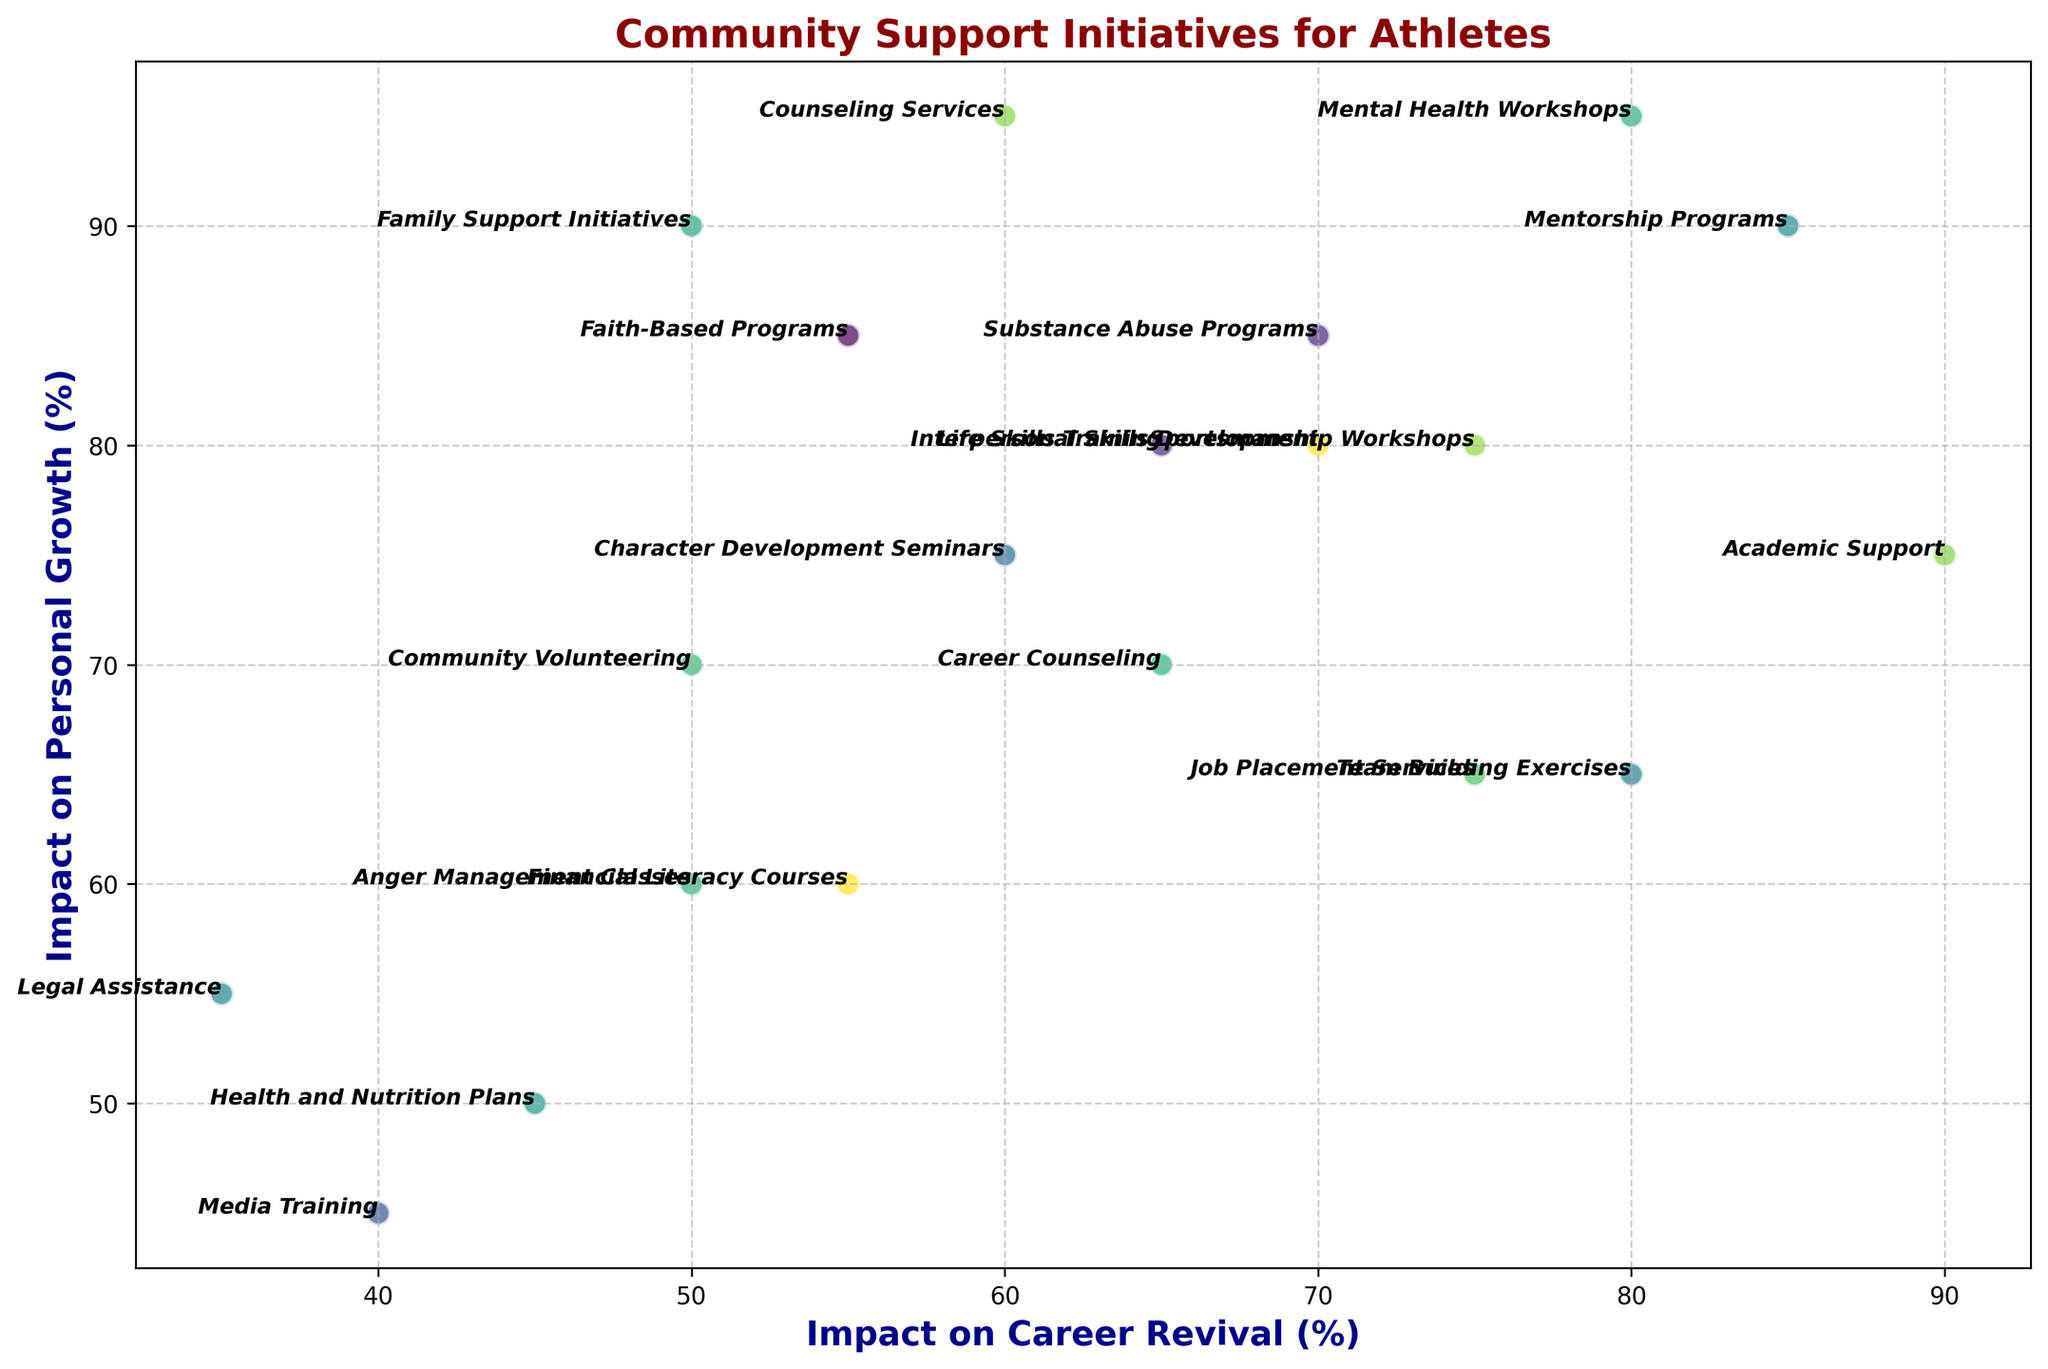What's the initiative with the highest impact on personal growth? The initiative with the highest "Impact on Personal Growth" will be the one with the highest value on the y-axis. By looking at the plot, you can identify that "Counseling Services" and "Mental Health Workshops" both have the highest mark at 95%.
Answer: Counseling Services and Mental Health Workshops Which initiative has the lowest impact on career revival? The initiative with the lowest "Impact on Career Revival" will be the one with the lowest value on the x-axis. By examining the plot, "Legal Assistance" appears at the lowest point of 35%.
Answer: Legal Assistance Compare the impact on career revival and personal growth for "Team Building Exercises" and "Community Volunteering". Which has a lower impact on personal growth? To answer, find the points for "Team Building Exercises" and "Community Volunteering" in terms of their y-axis values. "Team Building Exercises" has an impact on personal growth of 65%, while "Community Volunteering" has 70%. Therefore, "Team Building Exercises" has the lower impact on personal growth.
Answer: Team Building Exercises What is the average impact on personal growth for initiatives with above 70% impact on career revival? First, identify the initiatives with above 70% impact on career revival: "Sportsmanship Workshops", "Mentorship Programs", "Team Building Exercises", "Academic Support", "Mental Health Workshops", and "Job Placement Services". Their corresponding impacts on personal growth are 80%, 90%, 65%, 75%, 95%, and 65%. The average is calculated as (80+90+65+75+95+65)/6 = 78.33%.
Answer: 78.33% Which initiative has the lowest combined impact on career revival and personal growth? For each initiative, sum the values of "Impact on Career Revival" and "Impact on Personal Growth". By examining the sum for all initiatives, "Legal Assistance" has the lowest total (35 + 55 = 90).
Answer: Legal Assistance Is "Financial Literacy Courses" more impactful on career revival or personal growth? Look at the coordinates for "Financial Literacy Courses". It has an impact on career revival of 55% and an impact on personal growth of 60%. Thus, it is more impactful on personal growth.
Answer: Personal Growth Which initiative marks the highest impact on career revival compared to other initiatives? By examining the x-axis values, "Academic Support" stands out at 90%, marking the highest impact on career revival.
Answer: Academic Support Identify the initiative that equally impacts both career revival and personal growth. Locate the initiatives where the x and y values are equal or closely similar. No initiative has exactly equal values, but "Sportsmanship Workshops" (75% career revival, 80% personal growth) and "Life Skills Training" (65% career revival, 80% personal growth) have closely similar impacts. Yet, none meet the criteria exactly.
Answer: None exactly, closely Sportsmanship Workshops, Life Skills Training How does "Faith-Based Programs" visually distinguish itself in terms of personal growth? Check for the position of "Faith-Based Programs" on the y-axis to see its impact on personal growth. It is listed at 85%, making it among the higher achievers in personal growth.
Answer: High impact at 85% Do mentorship programs or counseling services have higher combined impact on career revival and personal growth? Summing the impacts for both initiatives: Mentorship Programs (85 + 90 = 175) and Counseling Services (60 + 95 = 155). Thus, Mentorship Programs have a higher combined impact.
Answer: Mentorship Programs 